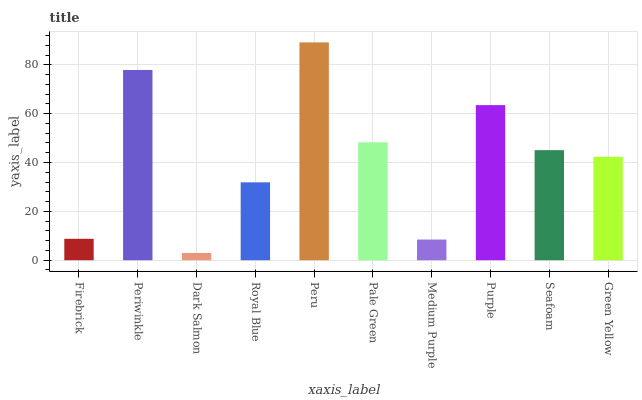Is Dark Salmon the minimum?
Answer yes or no. Yes. Is Peru the maximum?
Answer yes or no. Yes. Is Periwinkle the minimum?
Answer yes or no. No. Is Periwinkle the maximum?
Answer yes or no. No. Is Periwinkle greater than Firebrick?
Answer yes or no. Yes. Is Firebrick less than Periwinkle?
Answer yes or no. Yes. Is Firebrick greater than Periwinkle?
Answer yes or no. No. Is Periwinkle less than Firebrick?
Answer yes or no. No. Is Seafoam the high median?
Answer yes or no. Yes. Is Green Yellow the low median?
Answer yes or no. Yes. Is Green Yellow the high median?
Answer yes or no. No. Is Dark Salmon the low median?
Answer yes or no. No. 